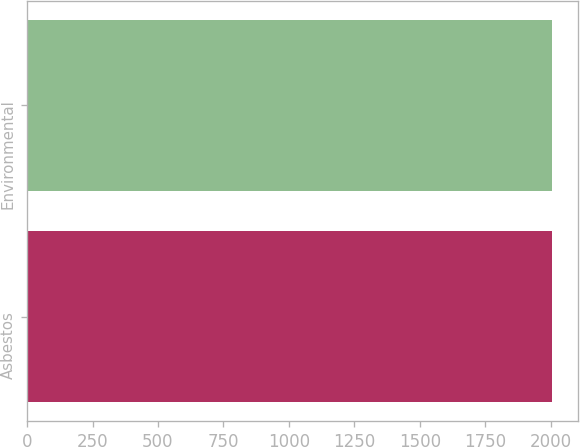Convert chart. <chart><loc_0><loc_0><loc_500><loc_500><bar_chart><fcel>Asbestos<fcel>Environmental<nl><fcel>2004<fcel>2004.1<nl></chart> 